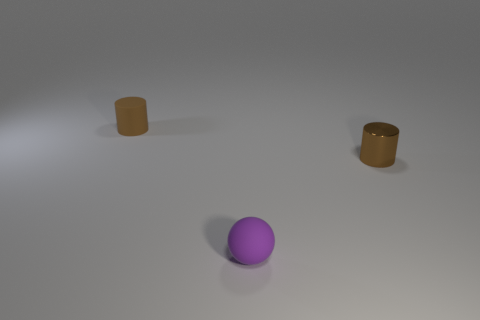Is the number of small shiny cylinders on the left side of the purple matte thing the same as the number of purple rubber objects that are right of the brown shiny cylinder? Indeed, the number of small shiny cylinders on the left of the purple matte sphere matches the quantity of purple rubber items to the right of the brown shiny cylinder, with both counts being zero, as there are no objects of such descriptions in the image. 